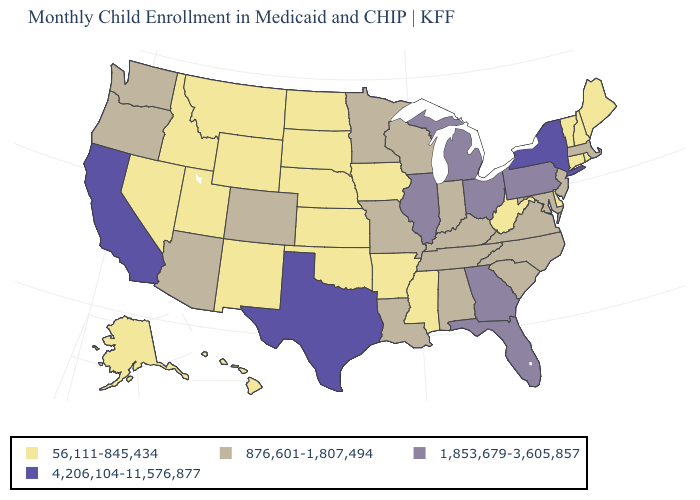What is the value of Oklahoma?
Quick response, please. 56,111-845,434. What is the value of Idaho?
Be succinct. 56,111-845,434. What is the highest value in states that border Massachusetts?
Short answer required. 4,206,104-11,576,877. What is the value of New Mexico?
Give a very brief answer. 56,111-845,434. Does the map have missing data?
Be succinct. No. Which states have the lowest value in the South?
Be succinct. Arkansas, Delaware, Mississippi, Oklahoma, West Virginia. What is the lowest value in the West?
Be succinct. 56,111-845,434. Among the states that border South Carolina , does Georgia have the highest value?
Quick response, please. Yes. Which states hav the highest value in the Northeast?
Answer briefly. New York. Name the states that have a value in the range 1,853,679-3,605,857?
Write a very short answer. Florida, Georgia, Illinois, Michigan, Ohio, Pennsylvania. Does Alabama have a higher value than Iowa?
Be succinct. Yes. How many symbols are there in the legend?
Be succinct. 4. Name the states that have a value in the range 1,853,679-3,605,857?
Short answer required. Florida, Georgia, Illinois, Michigan, Ohio, Pennsylvania. What is the value of Arizona?
Write a very short answer. 876,601-1,807,494. Which states have the lowest value in the South?
Give a very brief answer. Arkansas, Delaware, Mississippi, Oklahoma, West Virginia. 